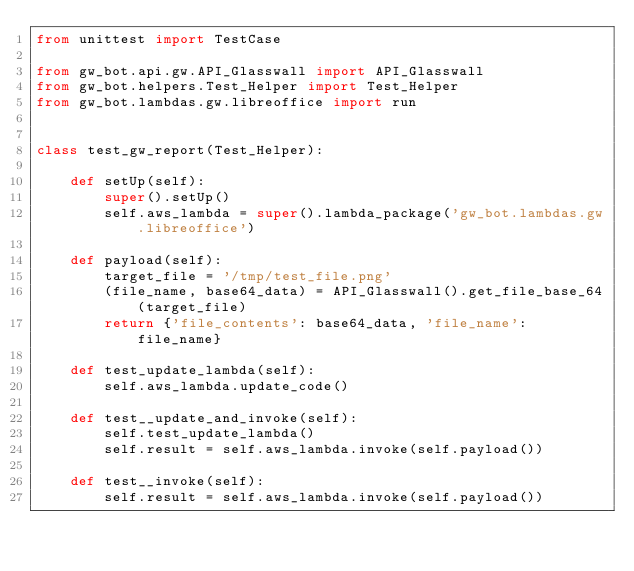Convert code to text. <code><loc_0><loc_0><loc_500><loc_500><_Python_>from unittest import TestCase

from gw_bot.api.gw.API_Glasswall import API_Glasswall
from gw_bot.helpers.Test_Helper import Test_Helper
from gw_bot.lambdas.gw.libreoffice import run


class test_gw_report(Test_Helper):

    def setUp(self):
        super().setUp()
        self.aws_lambda = super().lambda_package('gw_bot.lambdas.gw.libreoffice')

    def payload(self):
        target_file = '/tmp/test_file.png'
        (file_name, base64_data) = API_Glasswall().get_file_base_64(target_file)
        return {'file_contents': base64_data, 'file_name': file_name}

    def test_update_lambda(self):
        self.aws_lambda.update_code()

    def test__update_and_invoke(self):
        self.test_update_lambda()
        self.result = self.aws_lambda.invoke(self.payload())

    def test__invoke(self):
        self.result = self.aws_lambda.invoke(self.payload())
</code> 